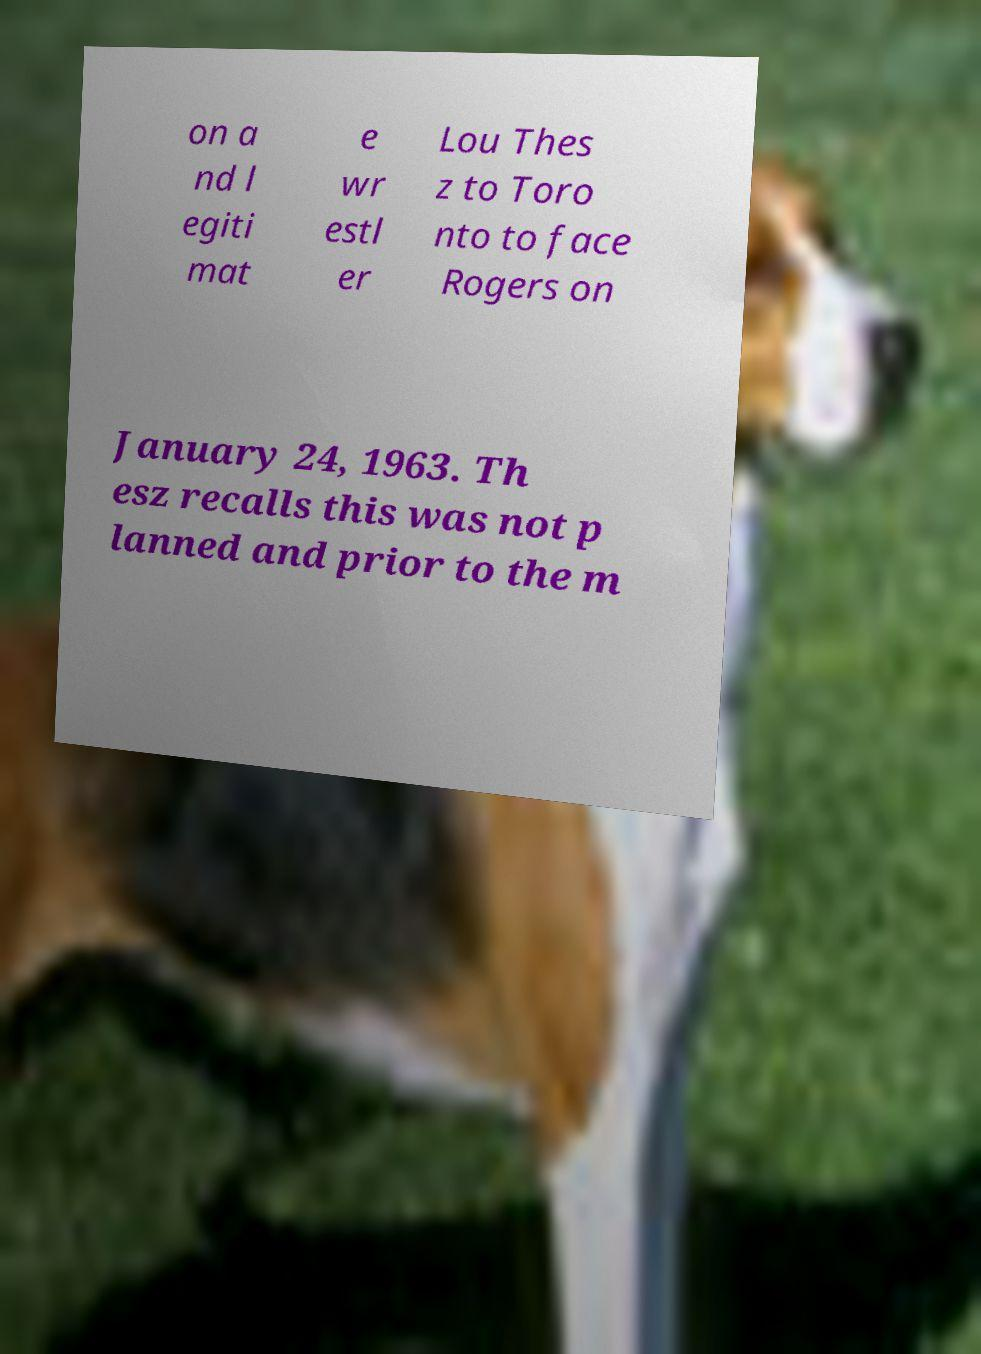Can you accurately transcribe the text from the provided image for me? on a nd l egiti mat e wr estl er Lou Thes z to Toro nto to face Rogers on January 24, 1963. Th esz recalls this was not p lanned and prior to the m 